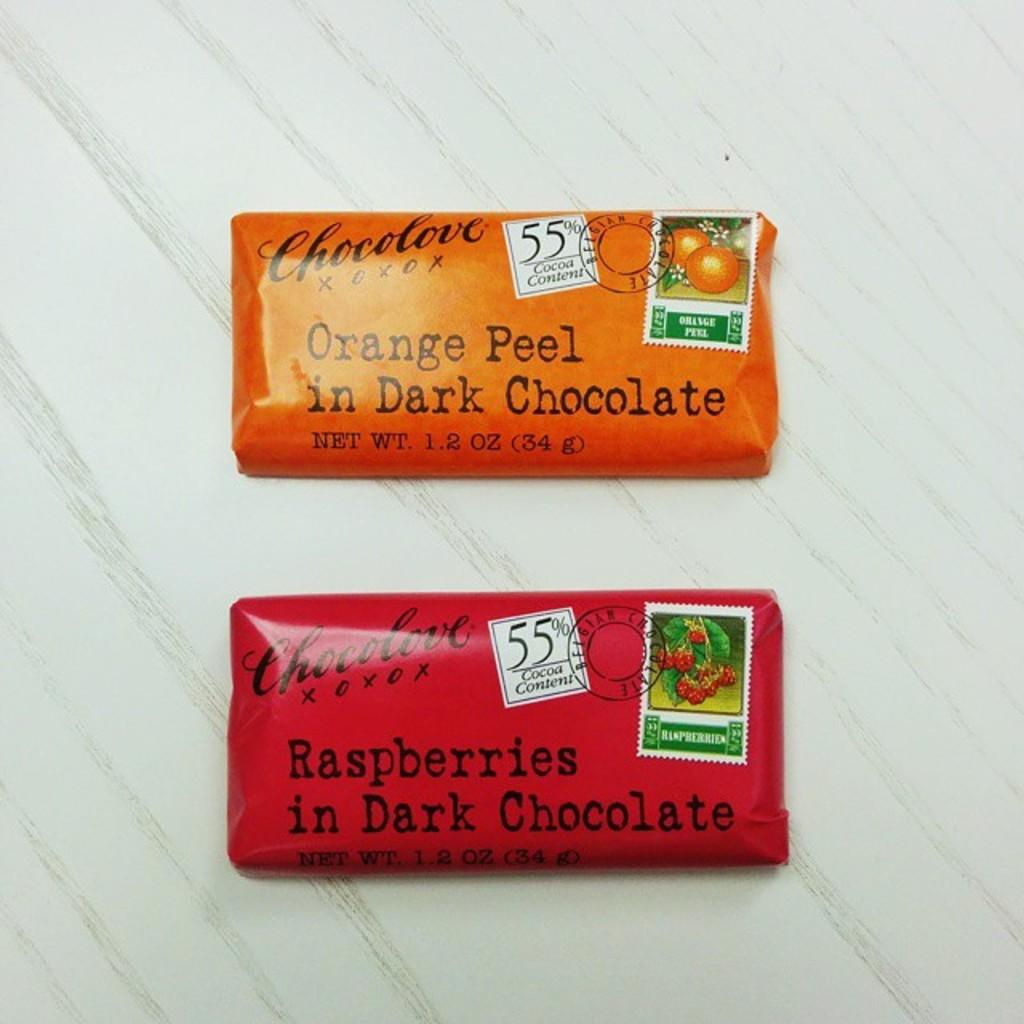<image>
Describe the image concisely. Two chocolate bars flavored with raspberries and orange peel. 